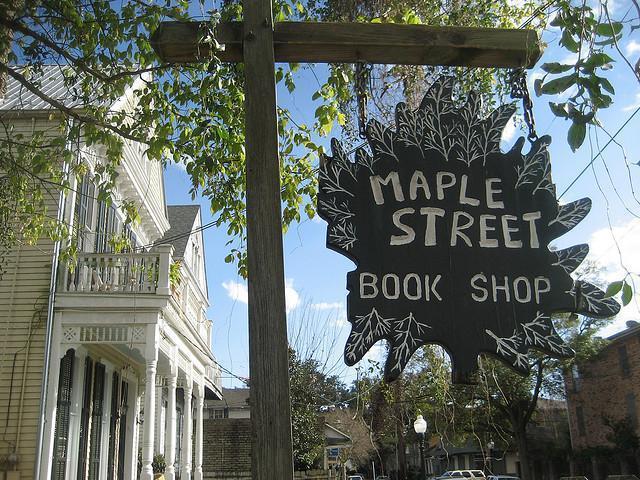How many signs are there on the post?
Give a very brief answer. 1. How many dogs are on a leash?
Give a very brief answer. 0. 